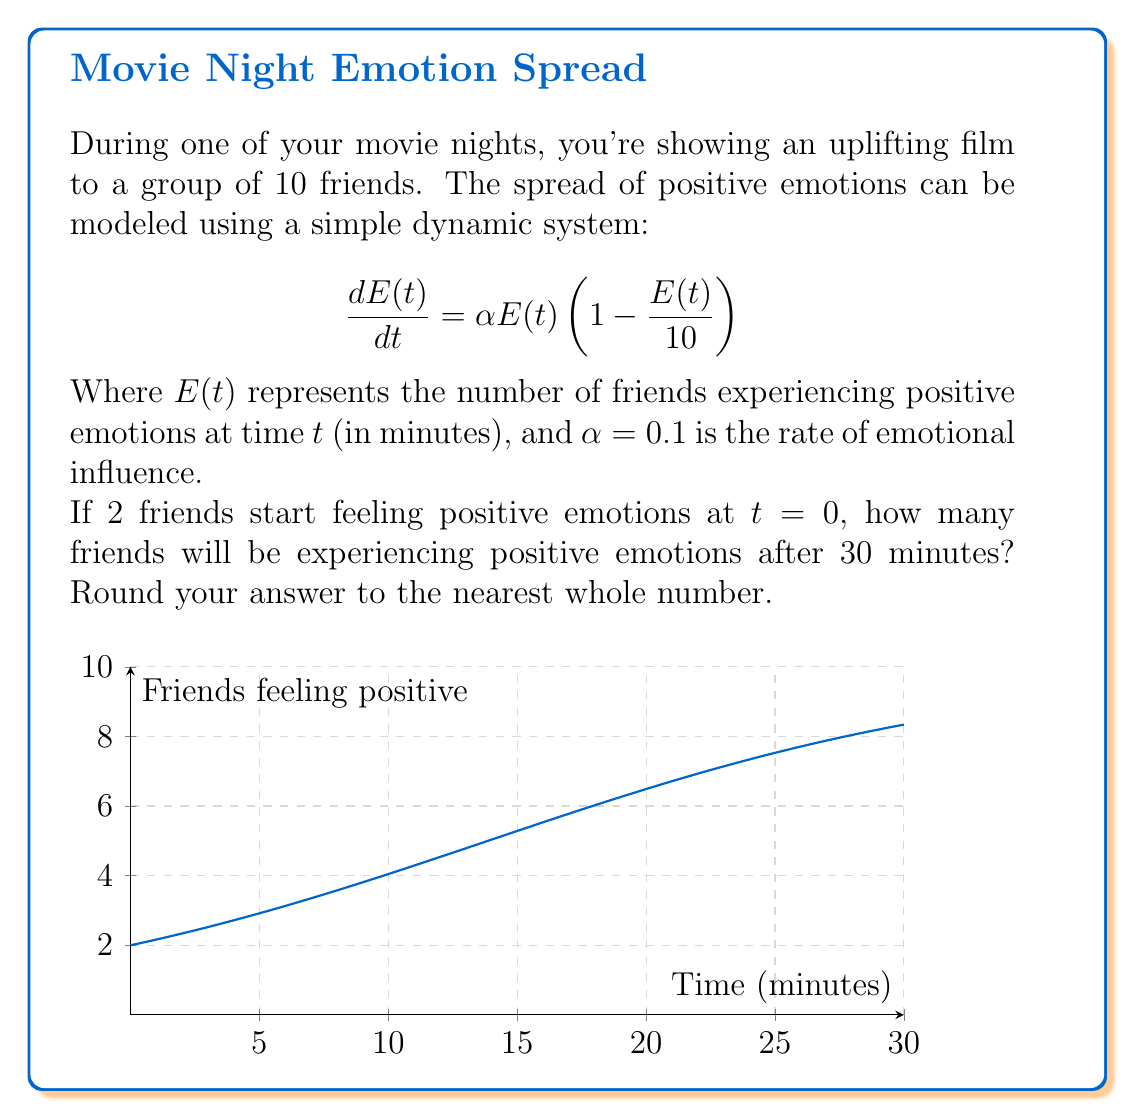Show me your answer to this math problem. Let's approach this step-by-step:

1) The given equation is a logistic growth model, where the maximum number of friends is 10.

2) The general solution for this type of equation is:

   $$E(t) = \frac{K}{1 + (\frac{K}{E_0} - 1)e^{-\alpha Kt}}$$

   Where $K$ is the carrying capacity (10 in this case), $E_0$ is the initial number of friends feeling positive (2), and $\alpha = 0.1$.

3) Substituting these values:

   $$E(t) = \frac{10}{1 + (\frac{10}{2} - 1)e^{-0.1 \cdot 10t}}$$

4) Simplify:

   $$E(t) = \frac{10}{1 + 4e^{-t}}$$

5) Now, we want to find $E(30)$:

   $$E(30) = \frac{10}{1 + 4e^{-30}}$$

6) Calculate:

   $$E(30) = \frac{10}{1 + 4e^{-3}} \approx 9.95$$

7) Rounding to the nearest whole number:

   $E(30) \approx 10$
Answer: 10 friends 